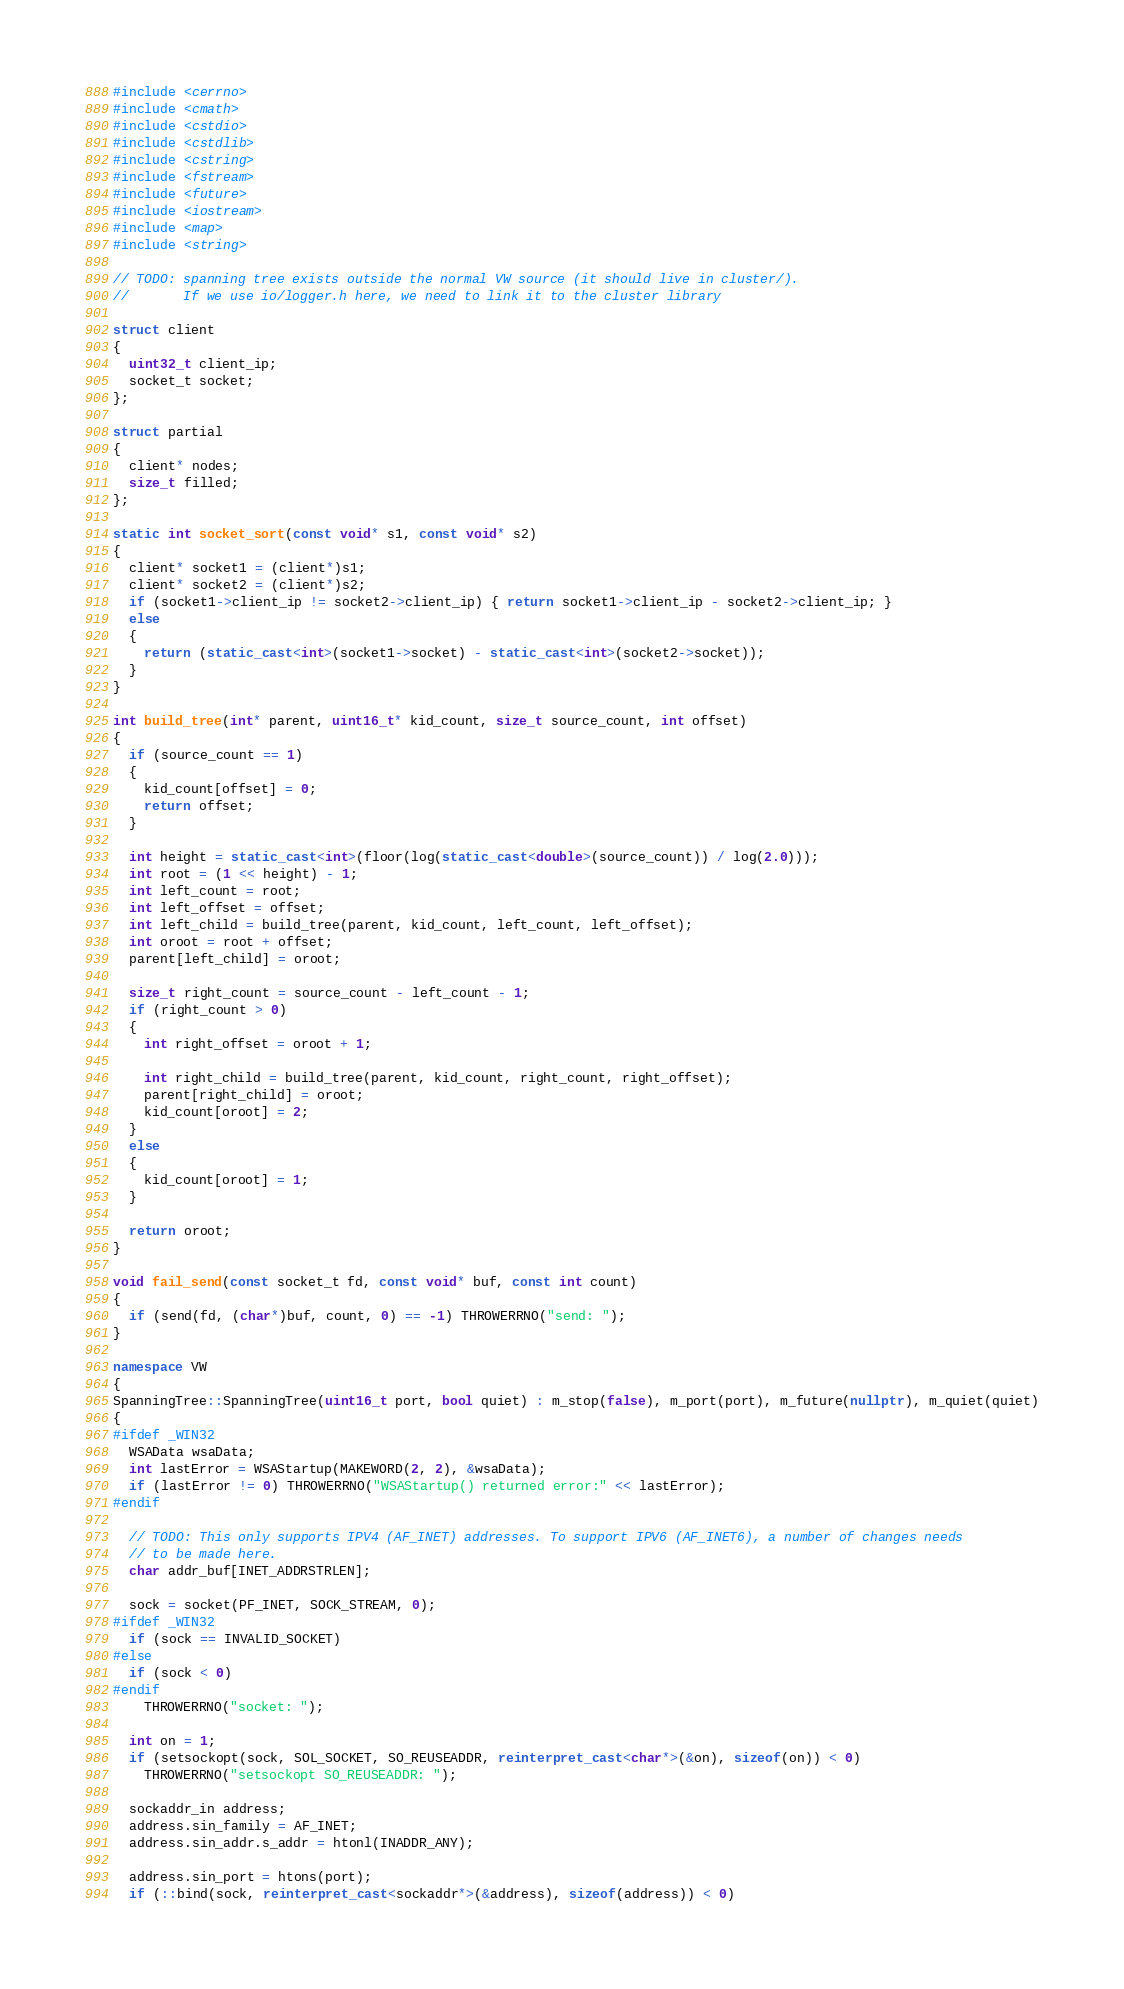<code> <loc_0><loc_0><loc_500><loc_500><_C++_>
#include <cerrno>
#include <cmath>
#include <cstdio>
#include <cstdlib>
#include <cstring>
#include <fstream>
#include <future>
#include <iostream>
#include <map>
#include <string>

// TODO: spanning tree exists outside the normal VW source (it should live in cluster/).
//       If we use io/logger.h here, we need to link it to the cluster library

struct client
{
  uint32_t client_ip;
  socket_t socket;
};

struct partial
{
  client* nodes;
  size_t filled;
};

static int socket_sort(const void* s1, const void* s2)
{
  client* socket1 = (client*)s1;
  client* socket2 = (client*)s2;
  if (socket1->client_ip != socket2->client_ip) { return socket1->client_ip - socket2->client_ip; }
  else
  {
    return (static_cast<int>(socket1->socket) - static_cast<int>(socket2->socket));
  }
}

int build_tree(int* parent, uint16_t* kid_count, size_t source_count, int offset)
{
  if (source_count == 1)
  {
    kid_count[offset] = 0;
    return offset;
  }

  int height = static_cast<int>(floor(log(static_cast<double>(source_count)) / log(2.0)));
  int root = (1 << height) - 1;
  int left_count = root;
  int left_offset = offset;
  int left_child = build_tree(parent, kid_count, left_count, left_offset);
  int oroot = root + offset;
  parent[left_child] = oroot;

  size_t right_count = source_count - left_count - 1;
  if (right_count > 0)
  {
    int right_offset = oroot + 1;

    int right_child = build_tree(parent, kid_count, right_count, right_offset);
    parent[right_child] = oroot;
    kid_count[oroot] = 2;
  }
  else
  {
    kid_count[oroot] = 1;
  }

  return oroot;
}

void fail_send(const socket_t fd, const void* buf, const int count)
{
  if (send(fd, (char*)buf, count, 0) == -1) THROWERRNO("send: ");
}

namespace VW
{
SpanningTree::SpanningTree(uint16_t port, bool quiet) : m_stop(false), m_port(port), m_future(nullptr), m_quiet(quiet)
{
#ifdef _WIN32
  WSAData wsaData;
  int lastError = WSAStartup(MAKEWORD(2, 2), &wsaData);
  if (lastError != 0) THROWERRNO("WSAStartup() returned error:" << lastError);
#endif

  // TODO: This only supports IPV4 (AF_INET) addresses. To support IPV6 (AF_INET6), a number of changes needs
  // to be made here.
  char addr_buf[INET_ADDRSTRLEN];

  sock = socket(PF_INET, SOCK_STREAM, 0);
#ifdef _WIN32
  if (sock == INVALID_SOCKET)
#else
  if (sock < 0)
#endif
    THROWERRNO("socket: ");

  int on = 1;
  if (setsockopt(sock, SOL_SOCKET, SO_REUSEADDR, reinterpret_cast<char*>(&on), sizeof(on)) < 0)
    THROWERRNO("setsockopt SO_REUSEADDR: ");

  sockaddr_in address;
  address.sin_family = AF_INET;
  address.sin_addr.s_addr = htonl(INADDR_ANY);

  address.sin_port = htons(port);
  if (::bind(sock, reinterpret_cast<sockaddr*>(&address), sizeof(address)) < 0)</code> 